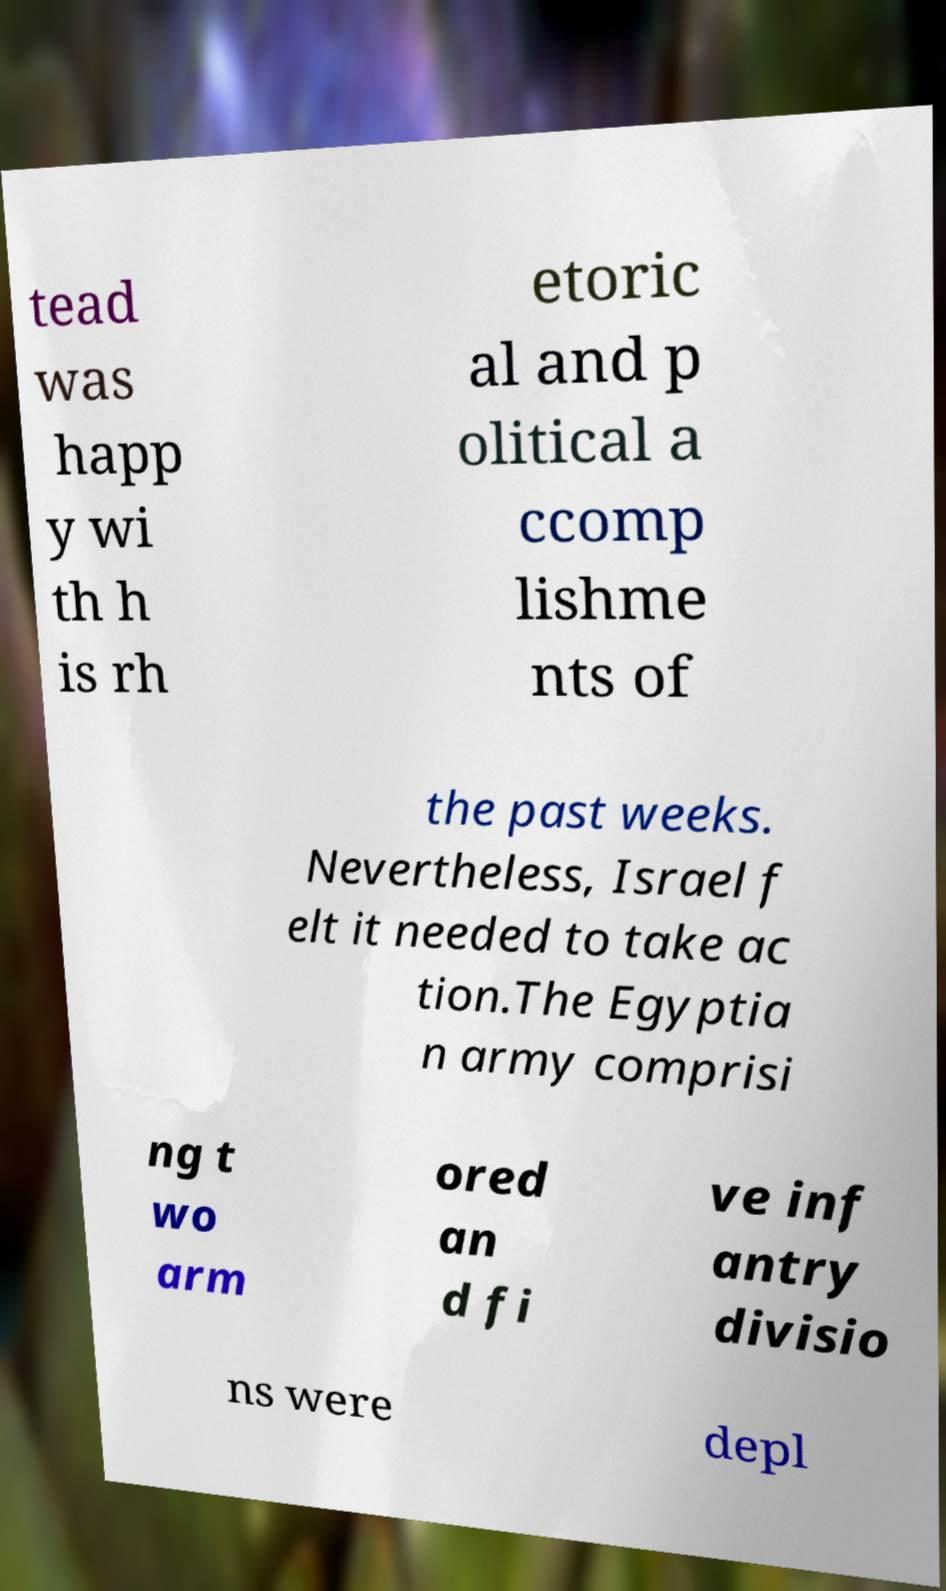Could you extract and type out the text from this image? tead was happ y wi th h is rh etoric al and p olitical a ccomp lishme nts of the past weeks. Nevertheless, Israel f elt it needed to take ac tion.The Egyptia n army comprisi ng t wo arm ored an d fi ve inf antry divisio ns were depl 